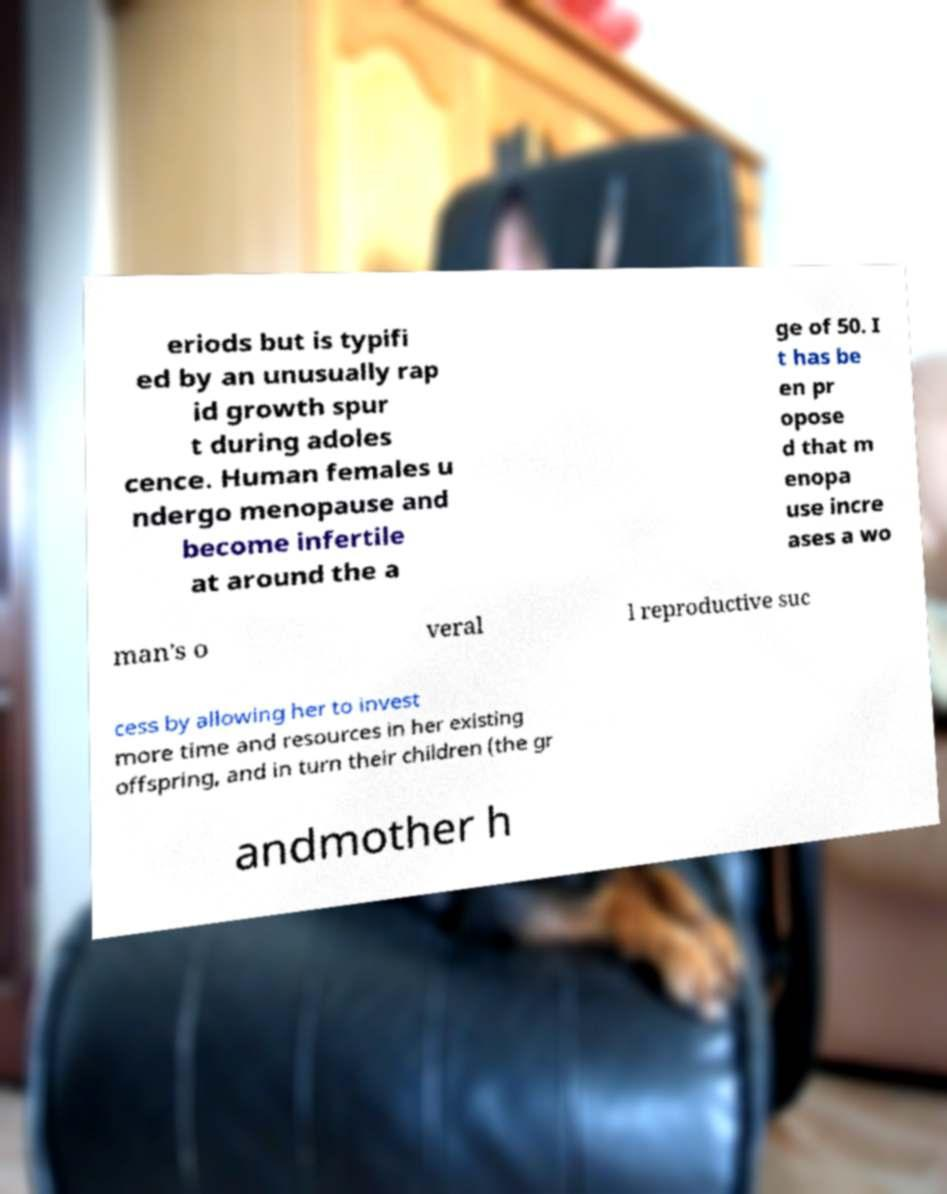What messages or text are displayed in this image? I need them in a readable, typed format. eriods but is typifi ed by an unusually rap id growth spur t during adoles cence. Human females u ndergo menopause and become infertile at around the a ge of 50. I t has be en pr opose d that m enopa use incre ases a wo man's o veral l reproductive suc cess by allowing her to invest more time and resources in her existing offspring, and in turn their children (the gr andmother h 